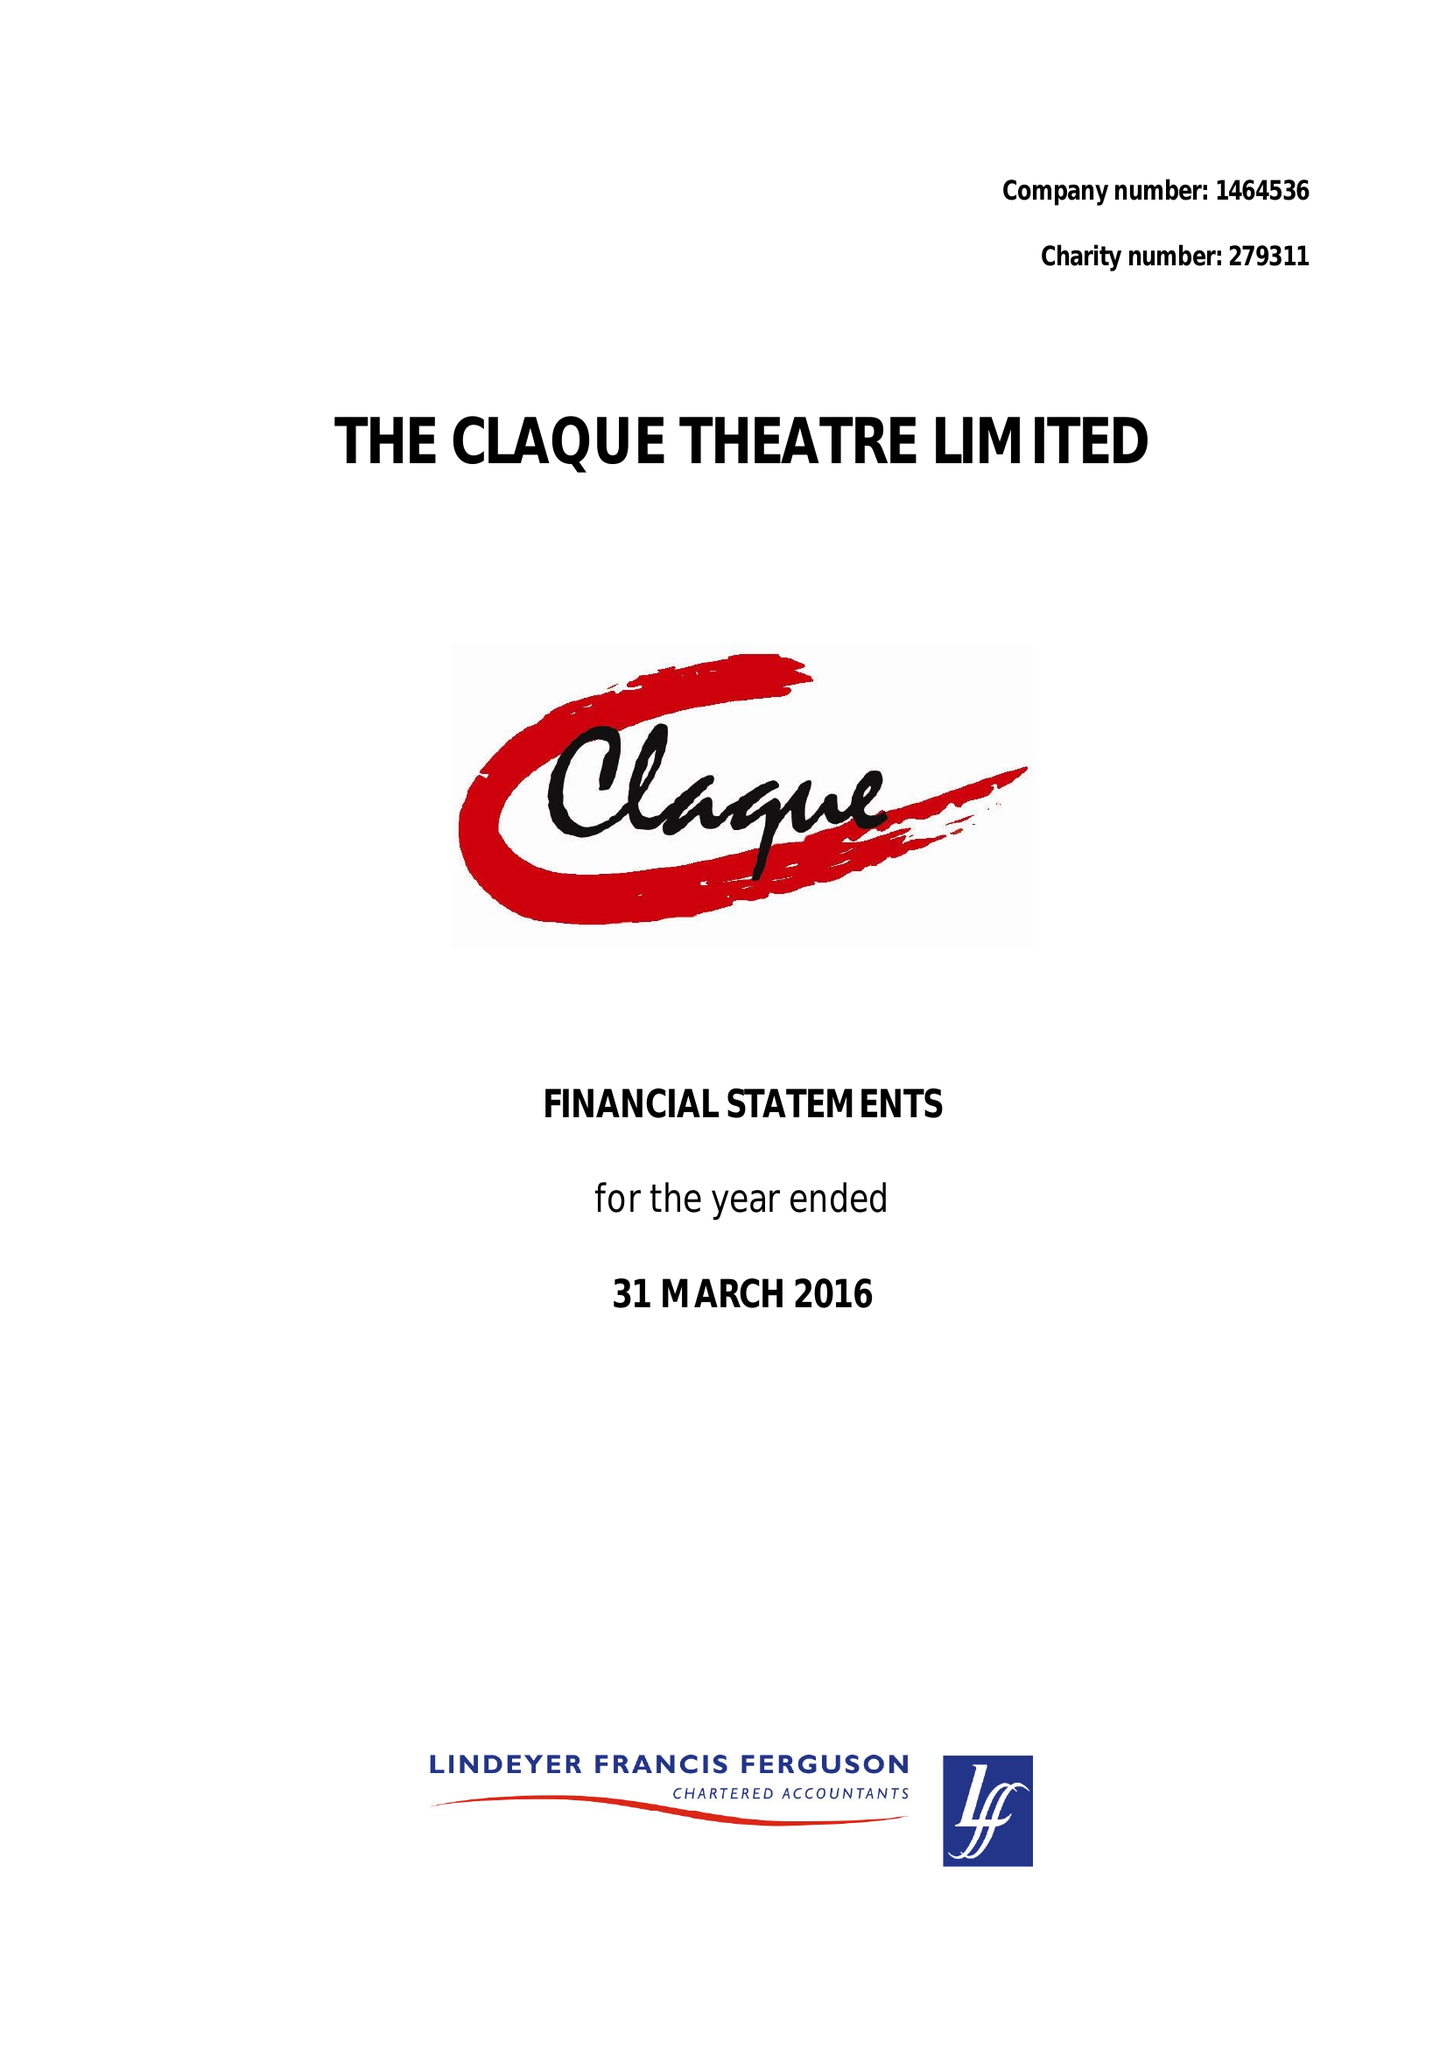What is the value for the address__post_town?
Answer the question using a single word or phrase. TUNBRIDGE WELLS 